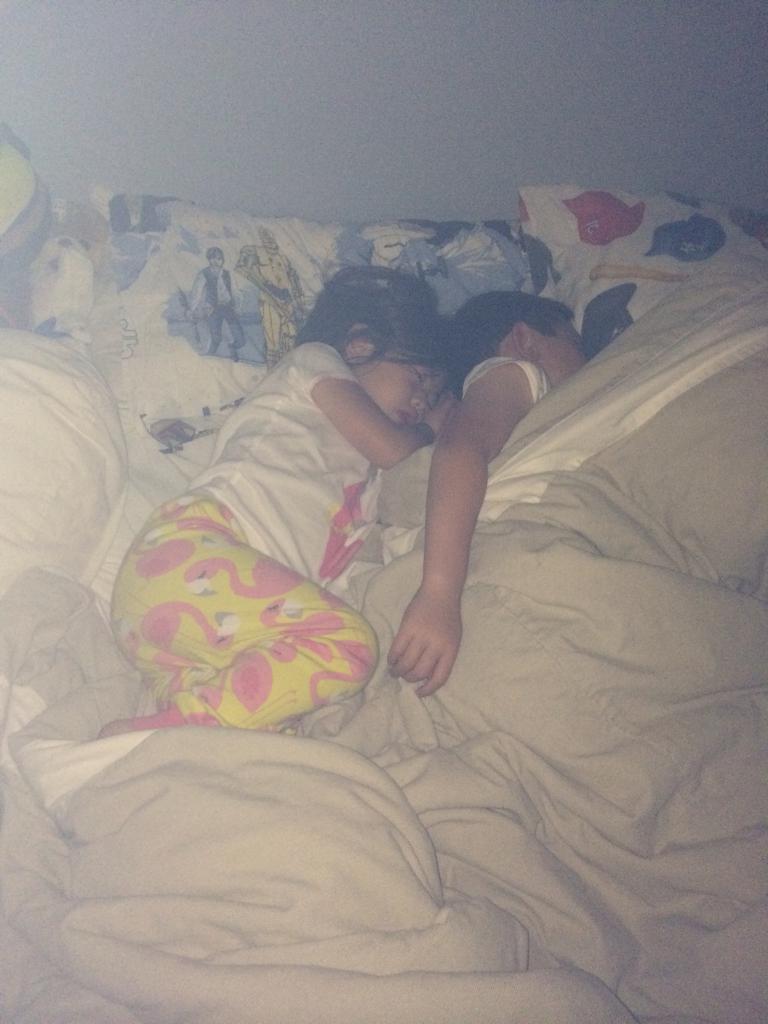Describe this image in one or two sentences. Here in this picture we can see two children sleeping on a bed and we can see pillows and bed sheets present. 